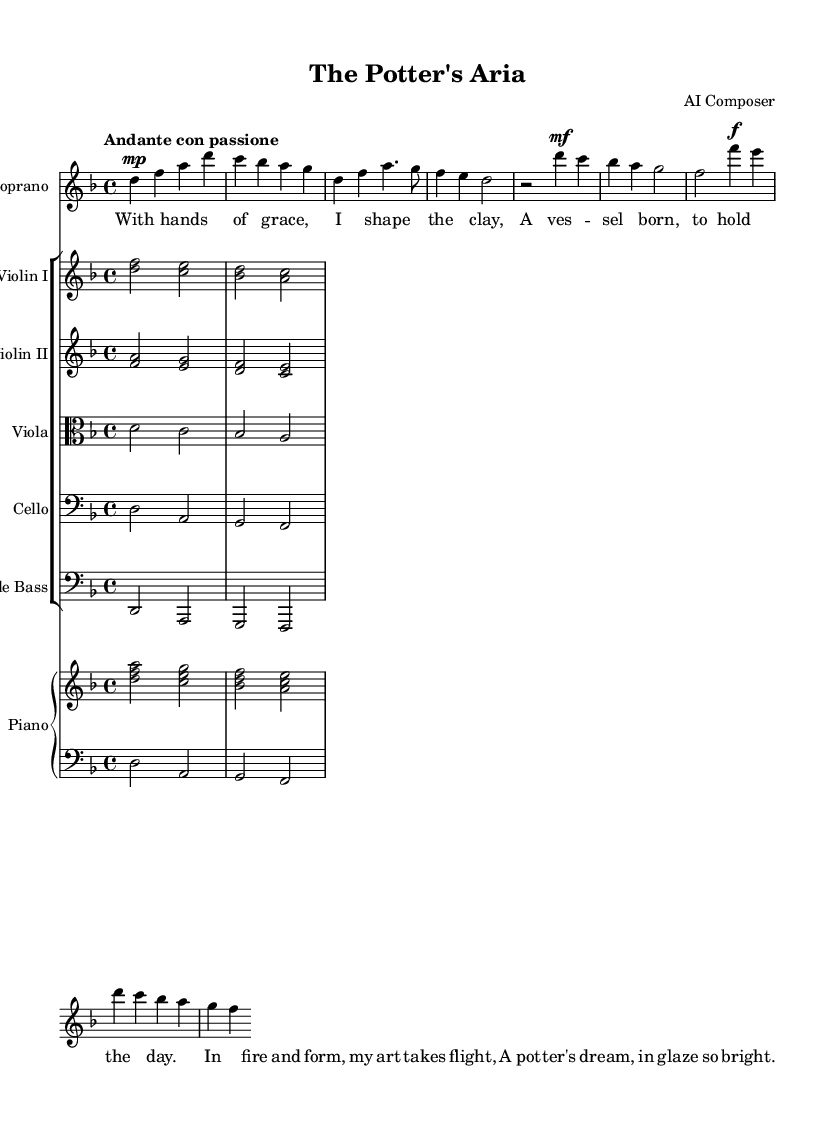What is the key signature of this music? The key signature is indicated by the number of sharps or flats shown at the beginning of the staff. In this case, the presence of one flat indicates the key of D minor.
Answer: D minor What is the time signature of this piece? The time signature is located at the beginning of the staff and shows how many beats are in each measure. Here, it is 4/4, meaning there are four beats per measure.
Answer: 4/4 What is the dynamic marking at the beginning of the soprano line? The dynamic marking is indicated by the abbreviation before the notes. In the soprano line, the marking is "mp," which stands for mezzo-piano, indicating a moderately soft volume.
Answer: mezzo-piano What is the tempo indication for this aria? The tempo indication is stated at the beginning with the term "Andante con passione." This means the piece should be played at a moderately slow speed with passion.
Answer: Andante con passione How many measures are in the chorus section? By counting the measure lines in the score, the chorus section has four measures: two measures for the starter and two additional measures.
Answer: 4 What artistic theme is depicted in this opera? The lyrics suggest the themes of pottery and craftsmanship, as they describe the act of shaping clay and the potter's dream of creating art.
Answer: Pottery and craftsmanship What instrument family is the violin part categorized in? The violin part is labeled as "Violin I" and "Violin II" within the score, indicating that it belongs to the string instrument family.
Answer: String 